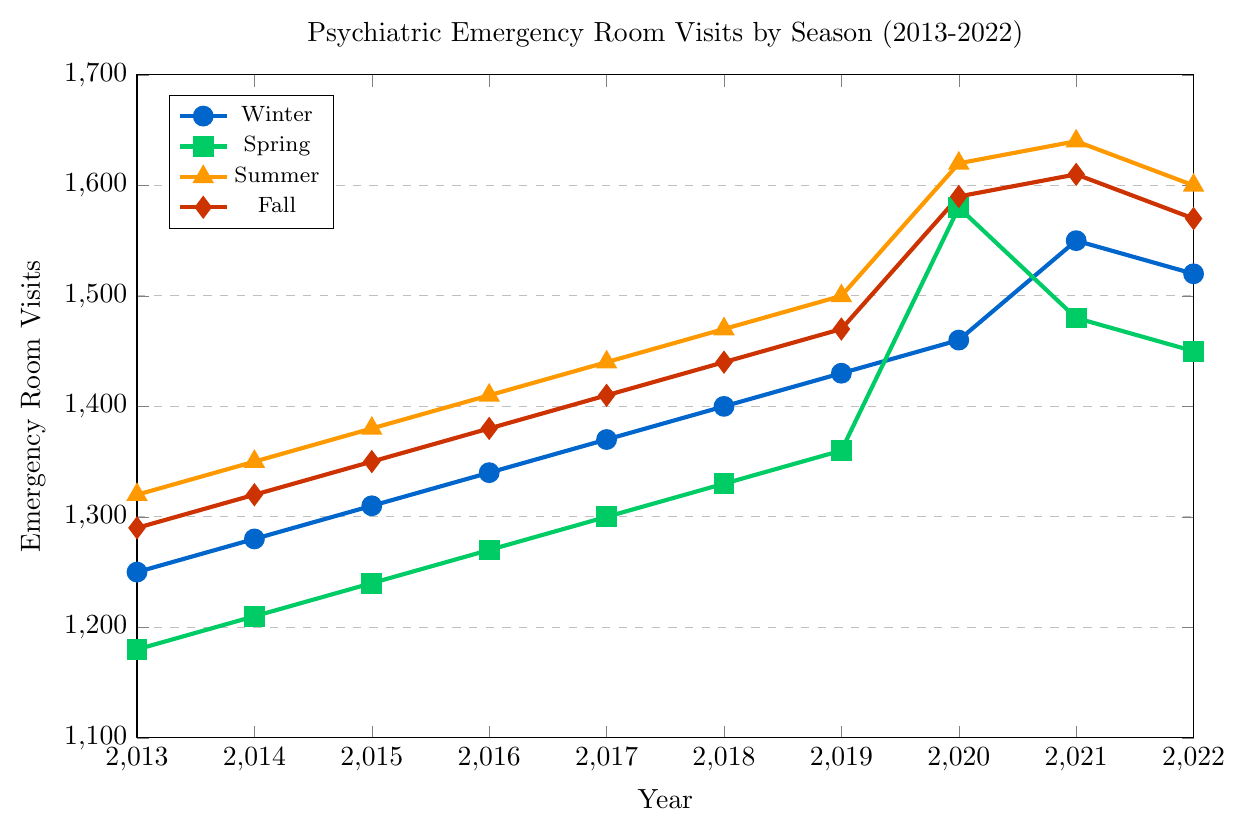Which season showed the highest increase in psychiatric emergency room visits between 2013 and 2022? Calculate the difference in emergency room visits in 2022 and 2013 for each season: Winter (1520-1250 = 270), Spring (1450-1180 = 270), Summer (1600-1320 = 280), Fall (1570-1290 = 280). Compare the differences: Summer and Fall both increased by 280.
Answer: Summer and Fall Did any season show a sudden spike in visits between any two consecutive years? Identify any significant jumps between consecutive years: Spring shows a spike from 2019 to 2020 (1580-1360 = 220) and Summer from 2019 to 2020 (1620-1500 = 120).
Answer: Yes, Spring and Summer in 2020 What is the overall trend in the number of psychiatric emergency room visits during Winter from 2013 to 2022? Analyze the values for Winter each year: 1250, 1280, 1310, 1340, 1370, 1400, 1430, 1460, 1550, 1520. The general trend shows a steady increase until 2021, followed by a slight decrease in 2022.
Answer: Generally increasing In which year was the maximum difference between Summer and Fall visits? Calculate differences each year between Summer and Fall: 2013 (1320-1290=30), 2014 (1350-1320=30), 2015 (1380-1350=30), 2016 (1410-1380=30), 2017 (1440-1410=30), 2018 (1470-1440=30), 2019 (1500-1470=30), 2020 (1620-1590=30), 2021 (1640-1610=30), 2022 (1600-1570=30). All differences are 30, so no maximum difference year.
Answer: All years the same, 30 Which season had the lowest number of visits in 2015? Refer to data points for 2015: Winter (1310), Spring (1240), Summer (1380), Fall (1350). Spring has the lowest visits.
Answer: Spring How did the number of Spring visits change from 2019 to 2020? Compare Spring visits in 2019 (1360) and 2020 (1580). The change is 1580 - 1360 = 220.
Answer: Increased by 220 What was the average number of visits in Summer from 2013 to 2018? Average visits for Summer from 2013 to 2018: (1320 + 1350 + 1380 + 1410 + 1440 + 1470) / 6 = 8370 / 6 = 1395.
Answer: 1395 Between which consecutive years did Fall visits show the smallest change? Compute differences: 2013-2014 (1320-1290=30), 2014-2015 (1350-1320=30), 2015-2016 (1380-1350=30), 2016-2017 (1410-1380=30), 2017-2018 (1440-1410=30), 2018-2019 (1470-1440=30), 2019-2020 (1590-1470=120), 2020-2021 (1610-1590=20), 2021-2022 (1570-1610=-40). The smallest change is between 2020 and 2021 (20).
Answer: 2020-2021 Was the number of visits in Winter ever higher than both Spring and Fall in the same year? Compare Winter with Spring and Fall each year: In 2021, Winter (1550) had more than Spring (1480) and Fall (1610). Other years show no such cases.
Answer: No Which season had the steepest overall increase in visits from 2013 to 2022? Calculate overall increase for each season: Winter (1520-1250=270), Spring (1450-1180=270), Summer (1600-1320=280), Fall (1570-1290=280). Both Summer and Fall had a 280-visit increase.
Answer: Summer and Fall 